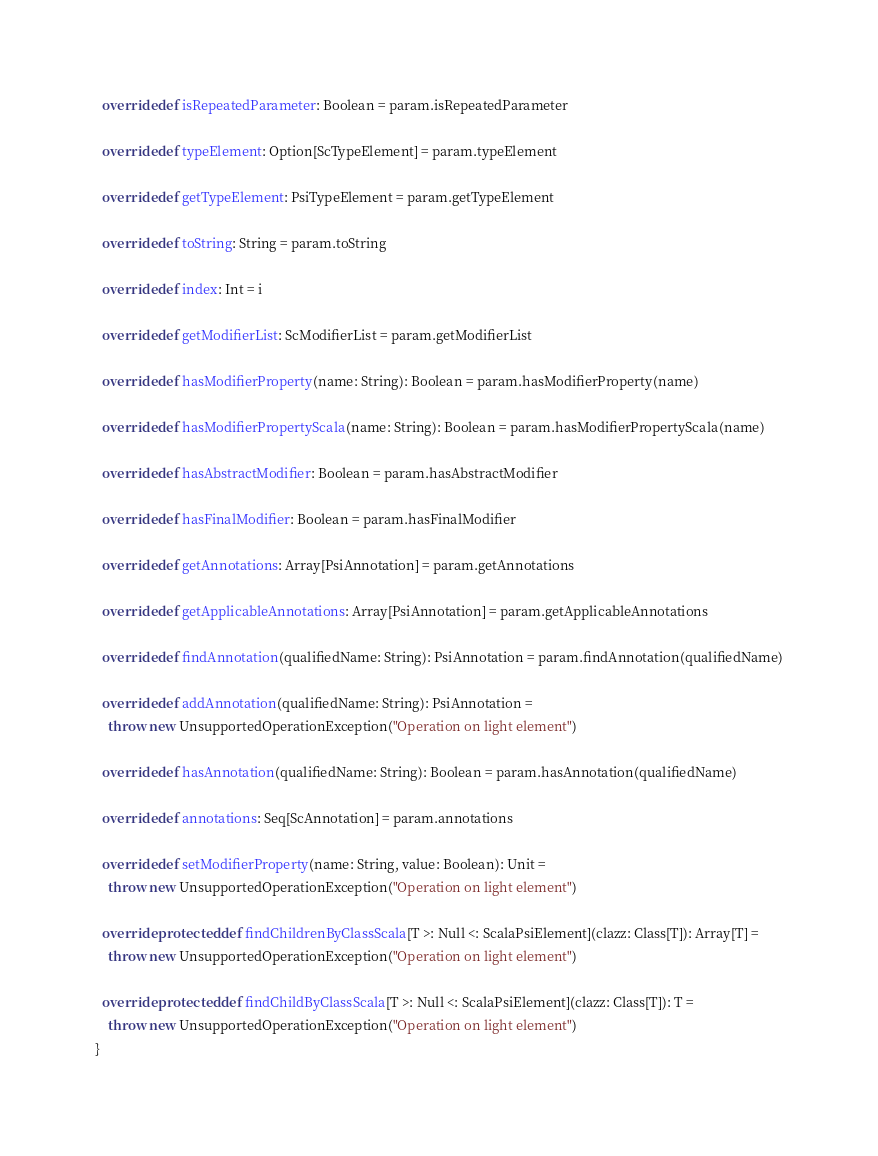<code> <loc_0><loc_0><loc_500><loc_500><_Scala_>  override def isRepeatedParameter: Boolean = param.isRepeatedParameter

  override def typeElement: Option[ScTypeElement] = param.typeElement

  override def getTypeElement: PsiTypeElement = param.getTypeElement

  override def toString: String = param.toString

  override def index: Int = i

  override def getModifierList: ScModifierList = param.getModifierList

  override def hasModifierProperty(name: String): Boolean = param.hasModifierProperty(name)

  override def hasModifierPropertyScala(name: String): Boolean = param.hasModifierPropertyScala(name)

  override def hasAbstractModifier: Boolean = param.hasAbstractModifier

  override def hasFinalModifier: Boolean = param.hasFinalModifier

  override def getAnnotations: Array[PsiAnnotation] = param.getAnnotations

  override def getApplicableAnnotations: Array[PsiAnnotation] = param.getApplicableAnnotations

  override def findAnnotation(qualifiedName: String): PsiAnnotation = param.findAnnotation(qualifiedName)

  override def addAnnotation(qualifiedName: String): PsiAnnotation =
    throw new UnsupportedOperationException("Operation on light element")

  override def hasAnnotation(qualifiedName: String): Boolean = param.hasAnnotation(qualifiedName)

  override def annotations: Seq[ScAnnotation] = param.annotations

  override def setModifierProperty(name: String, value: Boolean): Unit =
    throw new UnsupportedOperationException("Operation on light element")

  override protected def findChildrenByClassScala[T >: Null <: ScalaPsiElement](clazz: Class[T]): Array[T] =
    throw new UnsupportedOperationException("Operation on light element")

  override protected def findChildByClassScala[T >: Null <: ScalaPsiElement](clazz: Class[T]): T =
    throw new UnsupportedOperationException("Operation on light element")
}
</code> 